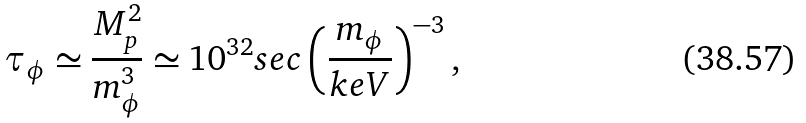<formula> <loc_0><loc_0><loc_500><loc_500>\tau _ { \phi } \simeq \frac { M _ { p } ^ { 2 } } { m _ { \phi } ^ { 3 } } \simeq 1 0 ^ { 3 2 } s e c \left ( \frac { m _ { \phi } } { k e V } \right ) ^ { - 3 } ,</formula> 